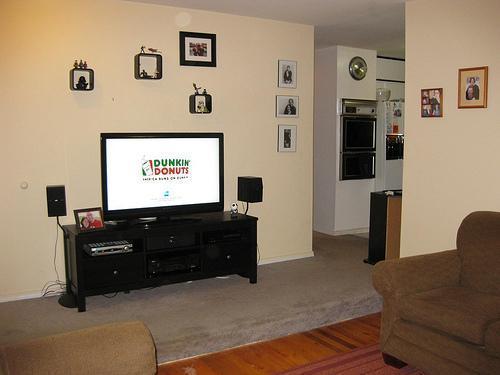How many couches are visible?
Give a very brief answer. 2. 